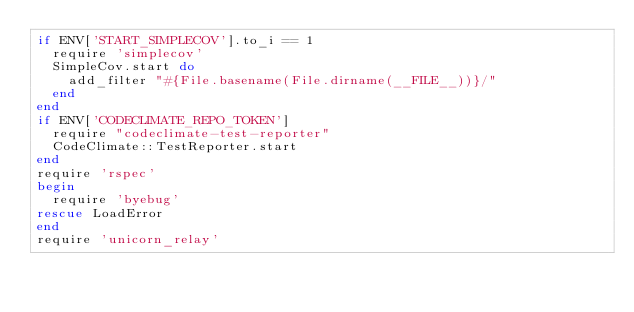<code> <loc_0><loc_0><loc_500><loc_500><_Ruby_>if ENV['START_SIMPLECOV'].to_i == 1
  require 'simplecov'
  SimpleCov.start do
    add_filter "#{File.basename(File.dirname(__FILE__))}/"
  end
end
if ENV['CODECLIMATE_REPO_TOKEN']
  require "codeclimate-test-reporter"
  CodeClimate::TestReporter.start
end
require 'rspec'
begin
  require 'byebug'
rescue LoadError
end
require 'unicorn_relay'
</code> 